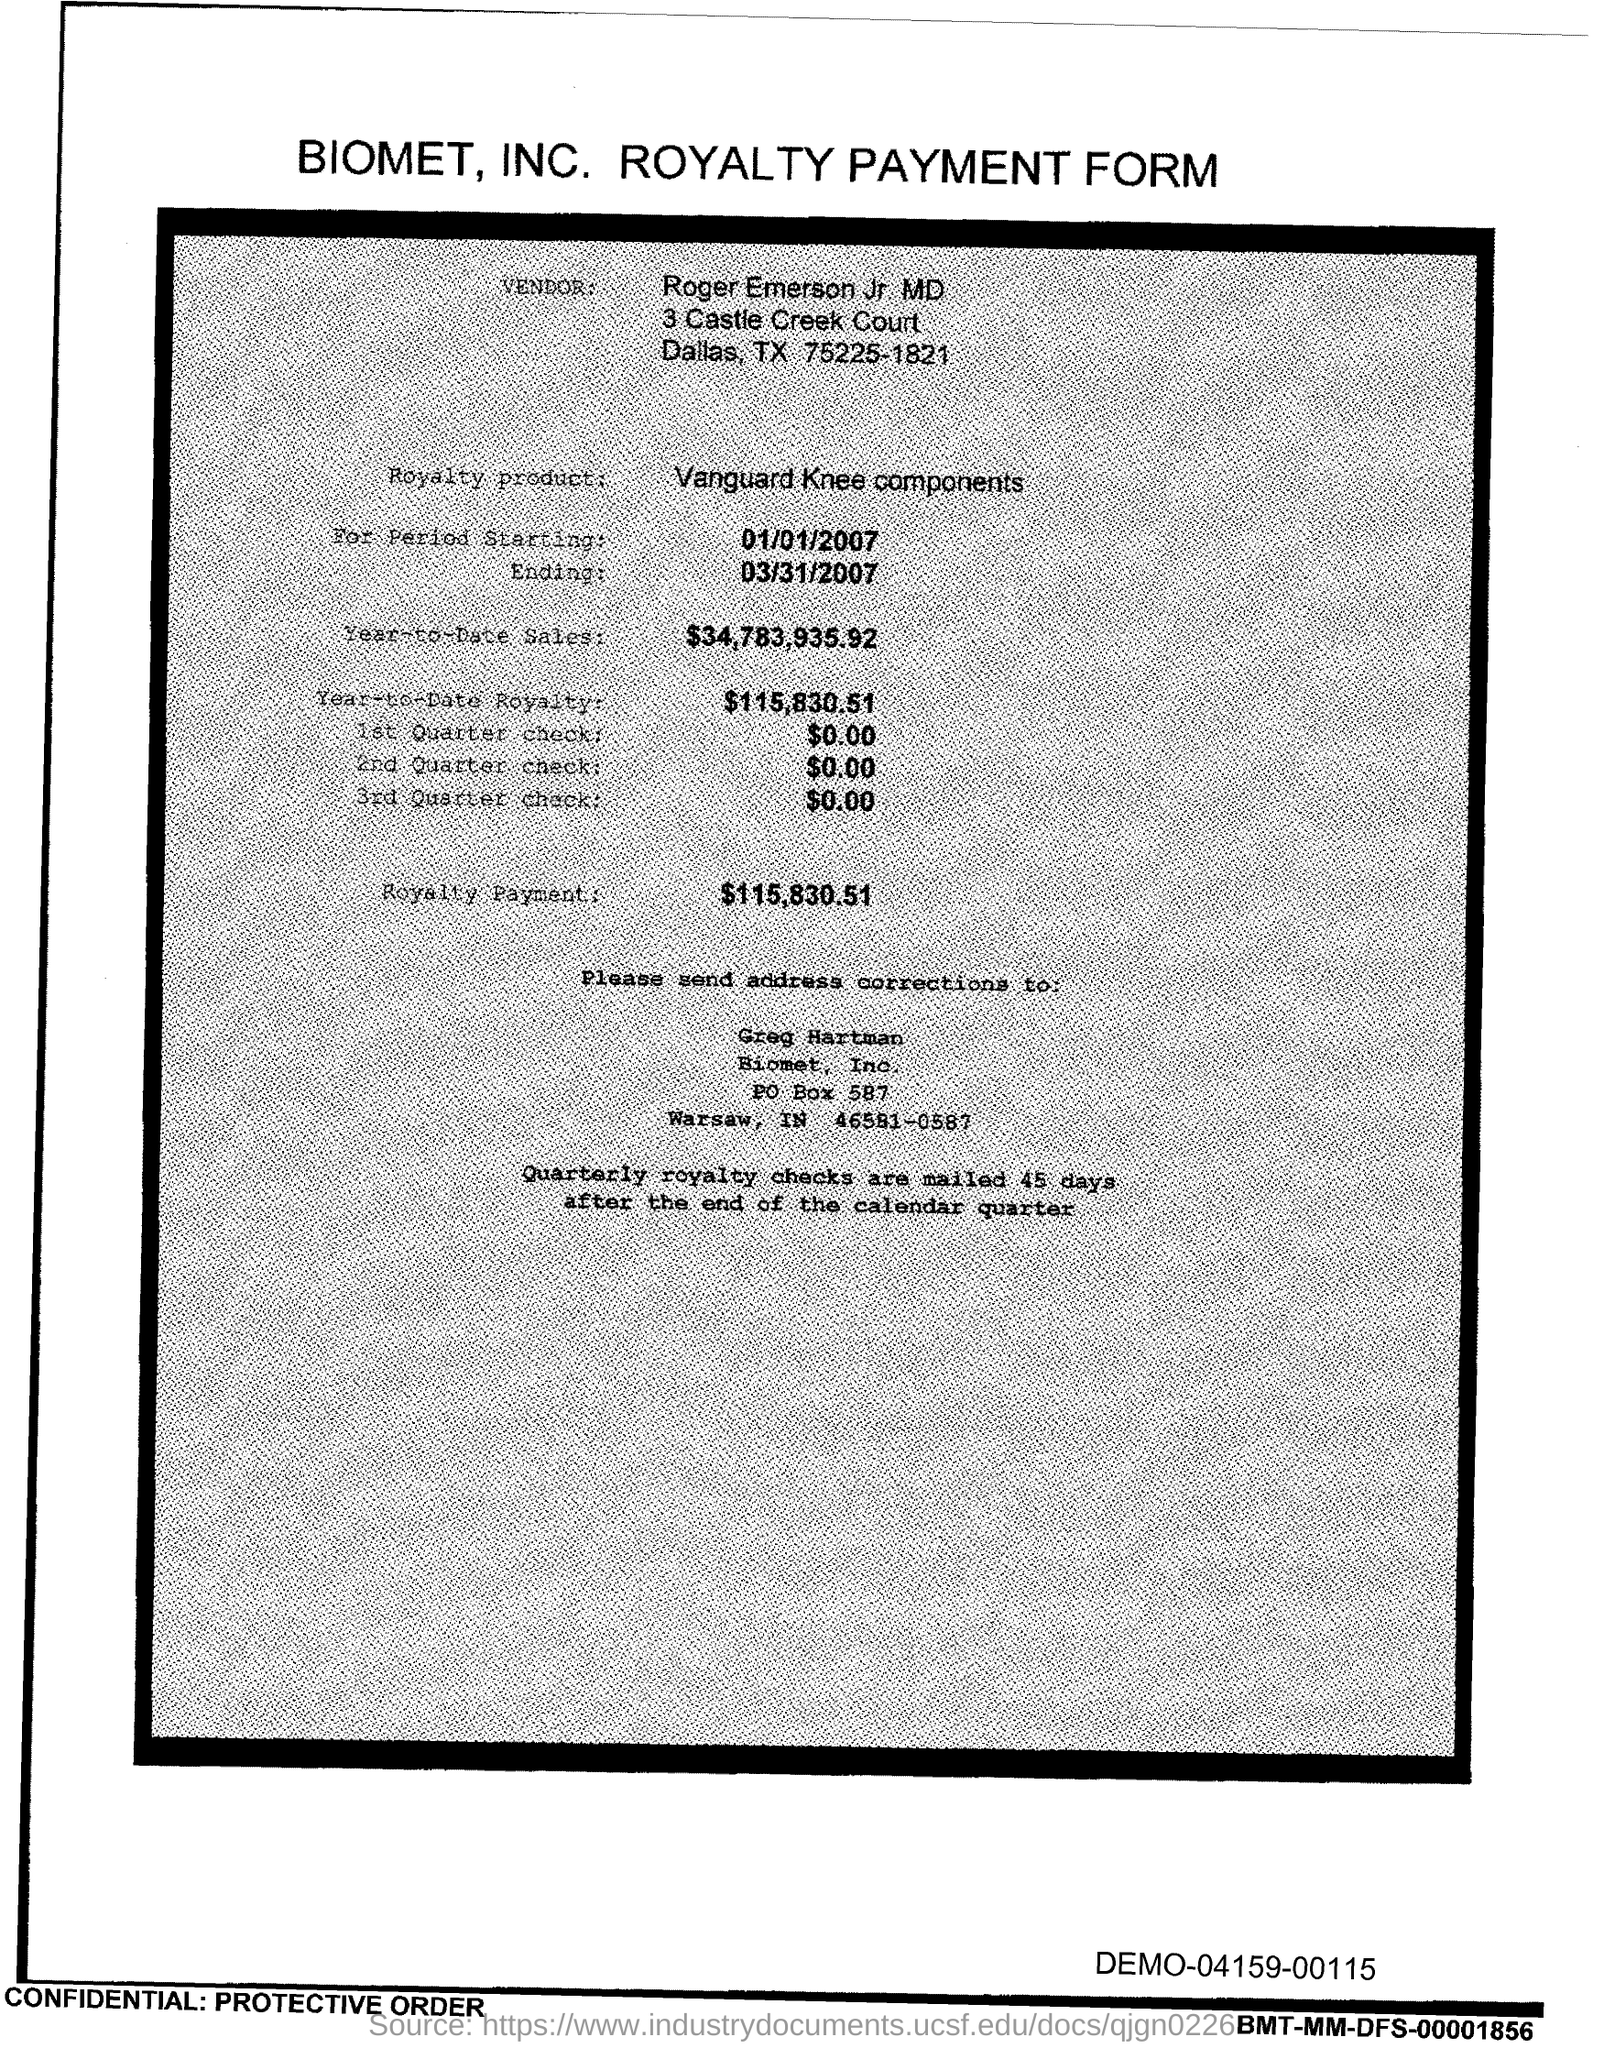What is the vendor name given in the form?
Your response must be concise. Roger Emerson Jr. MD. What is the royalty product given in the form?
Provide a short and direct response. Vanguard Knee components. What is the start date of the royalty period?
Make the answer very short. 01/01/2007. What is the Year-to-Date Sales of the royalty product?
Your answer should be very brief. $34,783,935.92. What is the Year-to-Date royalty of the product?
Provide a short and direct response. $115,830.51. What is the amount of 1st quarter check mentioned in the form?
Make the answer very short. $0.00. What is the end date of the royalty period?
Offer a terse response. 03/31/2007. What is the royalty payment of the product mentioned in the form?
Provide a succinct answer. $115,830.51. What is the amount of 2nd Quarter check mentioned in the form?
Your answer should be very brief. $0.00. 